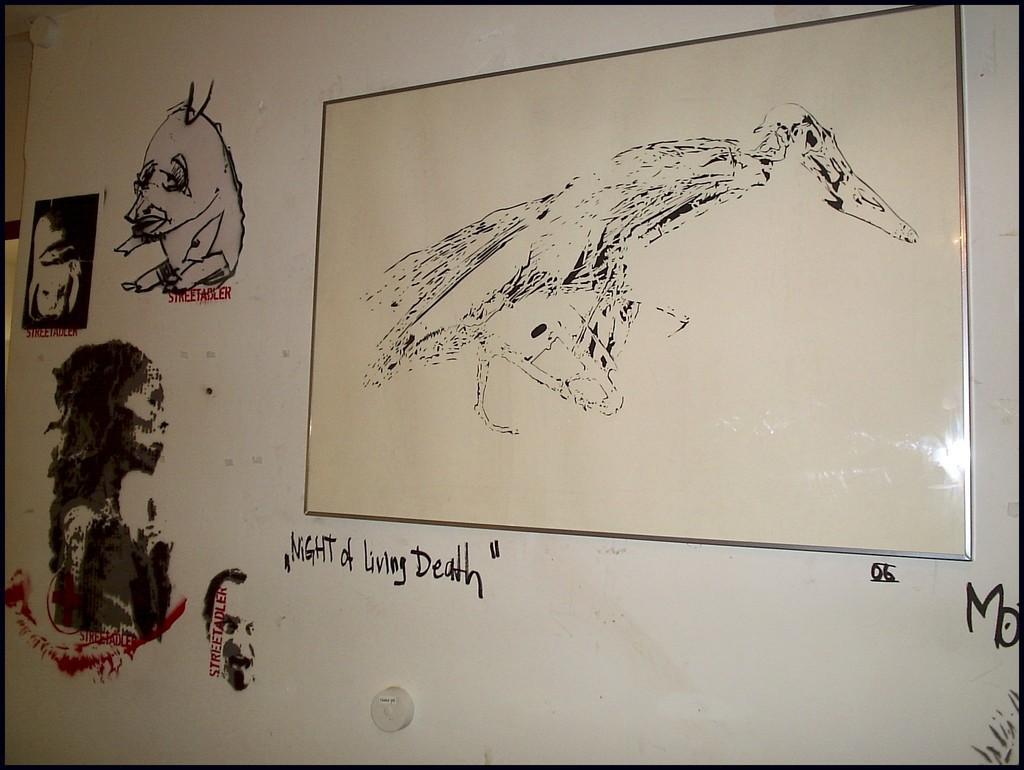Can you describe this image briefly? In this image we can see paintings, and text on the wall, also we can see the photo frame on the wall. 